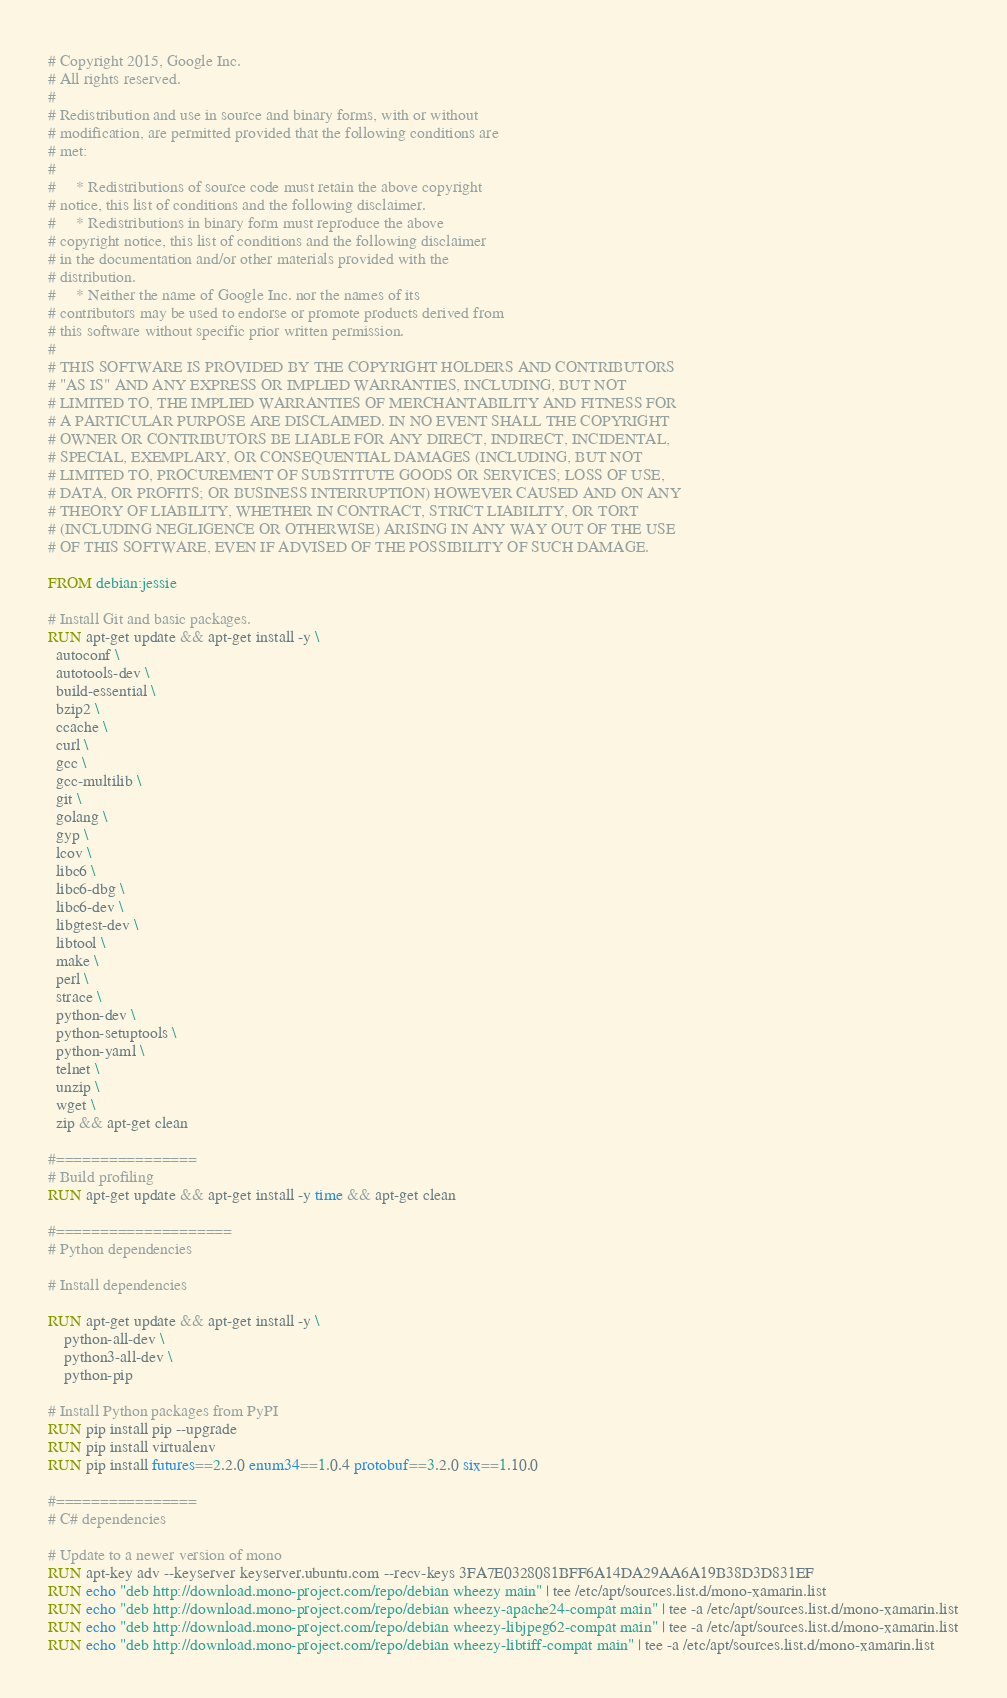<code> <loc_0><loc_0><loc_500><loc_500><_Dockerfile_># Copyright 2015, Google Inc.
# All rights reserved.
#
# Redistribution and use in source and binary forms, with or without
# modification, are permitted provided that the following conditions are
# met:
#
#     * Redistributions of source code must retain the above copyright
# notice, this list of conditions and the following disclaimer.
#     * Redistributions in binary form must reproduce the above
# copyright notice, this list of conditions and the following disclaimer
# in the documentation and/or other materials provided with the
# distribution.
#     * Neither the name of Google Inc. nor the names of its
# contributors may be used to endorse or promote products derived from
# this software without specific prior written permission.
#
# THIS SOFTWARE IS PROVIDED BY THE COPYRIGHT HOLDERS AND CONTRIBUTORS
# "AS IS" AND ANY EXPRESS OR IMPLIED WARRANTIES, INCLUDING, BUT NOT
# LIMITED TO, THE IMPLIED WARRANTIES OF MERCHANTABILITY AND FITNESS FOR
# A PARTICULAR PURPOSE ARE DISCLAIMED. IN NO EVENT SHALL THE COPYRIGHT
# OWNER OR CONTRIBUTORS BE LIABLE FOR ANY DIRECT, INDIRECT, INCIDENTAL,
# SPECIAL, EXEMPLARY, OR CONSEQUENTIAL DAMAGES (INCLUDING, BUT NOT
# LIMITED TO, PROCUREMENT OF SUBSTITUTE GOODS OR SERVICES; LOSS OF USE,
# DATA, OR PROFITS; OR BUSINESS INTERRUPTION) HOWEVER CAUSED AND ON ANY
# THEORY OF LIABILITY, WHETHER IN CONTRACT, STRICT LIABILITY, OR TORT
# (INCLUDING NEGLIGENCE OR OTHERWISE) ARISING IN ANY WAY OUT OF THE USE
# OF THIS SOFTWARE, EVEN IF ADVISED OF THE POSSIBILITY OF SUCH DAMAGE.

FROM debian:jessie

# Install Git and basic packages.
RUN apt-get update && apt-get install -y \
  autoconf \
  autotools-dev \
  build-essential \
  bzip2 \
  ccache \
  curl \
  gcc \
  gcc-multilib \
  git \
  golang \
  gyp \
  lcov \
  libc6 \
  libc6-dbg \
  libc6-dev \
  libgtest-dev \
  libtool \
  make \
  perl \
  strace \
  python-dev \
  python-setuptools \
  python-yaml \
  telnet \
  unzip \
  wget \
  zip && apt-get clean

#================
# Build profiling
RUN apt-get update && apt-get install -y time && apt-get clean

#====================
# Python dependencies

# Install dependencies

RUN apt-get update && apt-get install -y \
    python-all-dev \
    python3-all-dev \
    python-pip

# Install Python packages from PyPI
RUN pip install pip --upgrade
RUN pip install virtualenv
RUN pip install futures==2.2.0 enum34==1.0.4 protobuf==3.2.0 six==1.10.0

#================
# C# dependencies

# Update to a newer version of mono
RUN apt-key adv --keyserver keyserver.ubuntu.com --recv-keys 3FA7E0328081BFF6A14DA29AA6A19B38D3D831EF
RUN echo "deb http://download.mono-project.com/repo/debian wheezy main" | tee /etc/apt/sources.list.d/mono-xamarin.list
RUN echo "deb http://download.mono-project.com/repo/debian wheezy-apache24-compat main" | tee -a /etc/apt/sources.list.d/mono-xamarin.list
RUN echo "deb http://download.mono-project.com/repo/debian wheezy-libjpeg62-compat main" | tee -a /etc/apt/sources.list.d/mono-xamarin.list
RUN echo "deb http://download.mono-project.com/repo/debian wheezy-libtiff-compat main" | tee -a /etc/apt/sources.list.d/mono-xamarin.list
</code> 